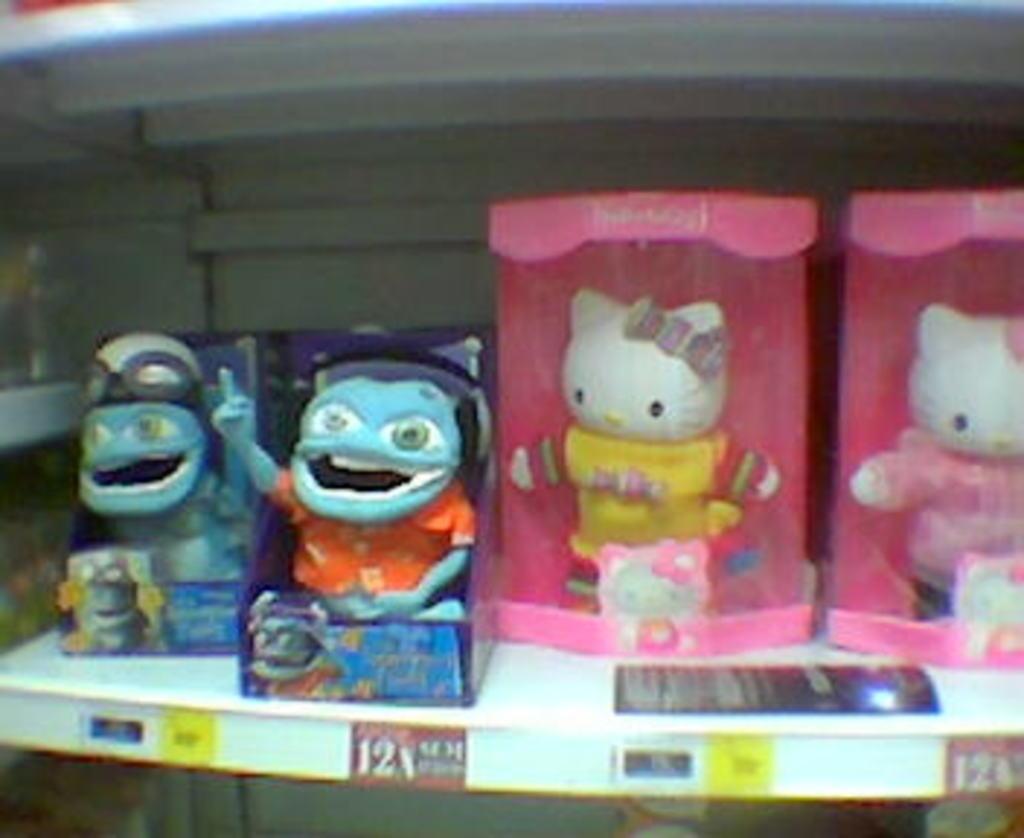Please provide a concise description of this image. This image consists of dolls. To the right, there are hello kitty's are kept in a rack. 